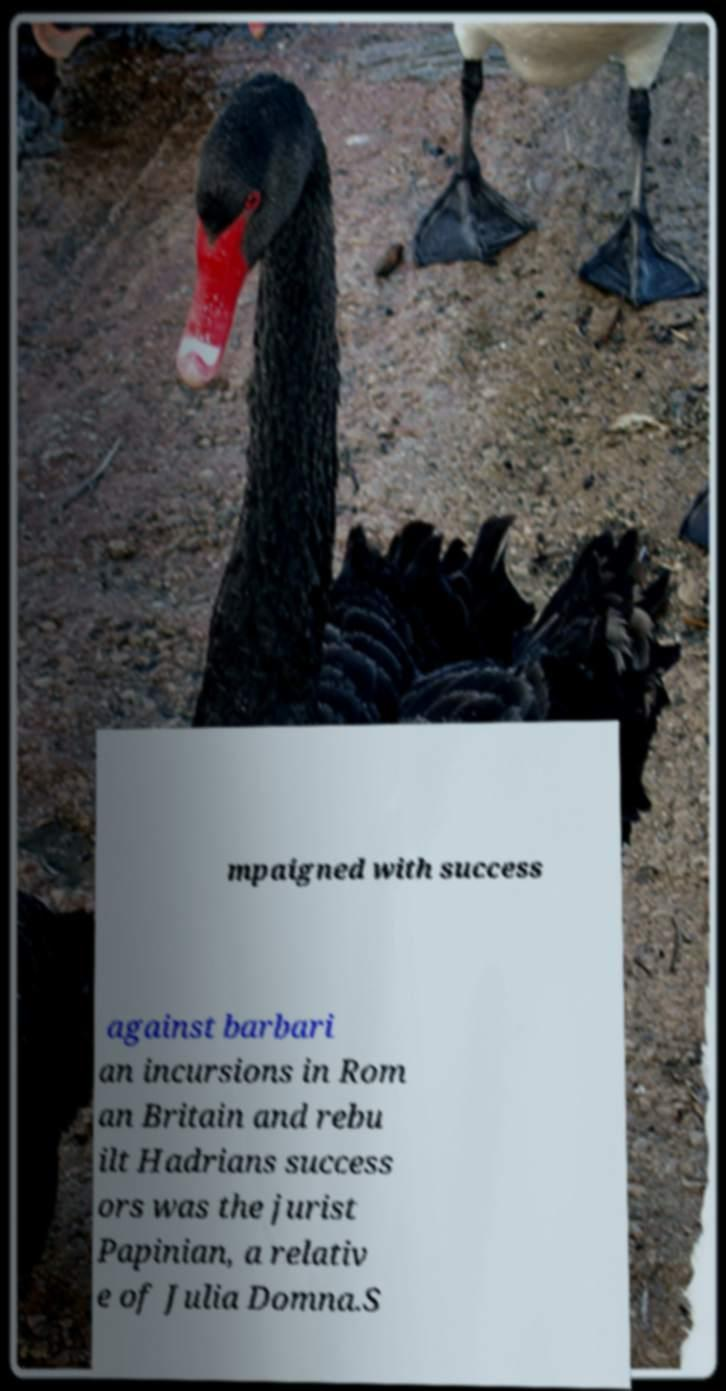There's text embedded in this image that I need extracted. Can you transcribe it verbatim? mpaigned with success against barbari an incursions in Rom an Britain and rebu ilt Hadrians success ors was the jurist Papinian, a relativ e of Julia Domna.S 